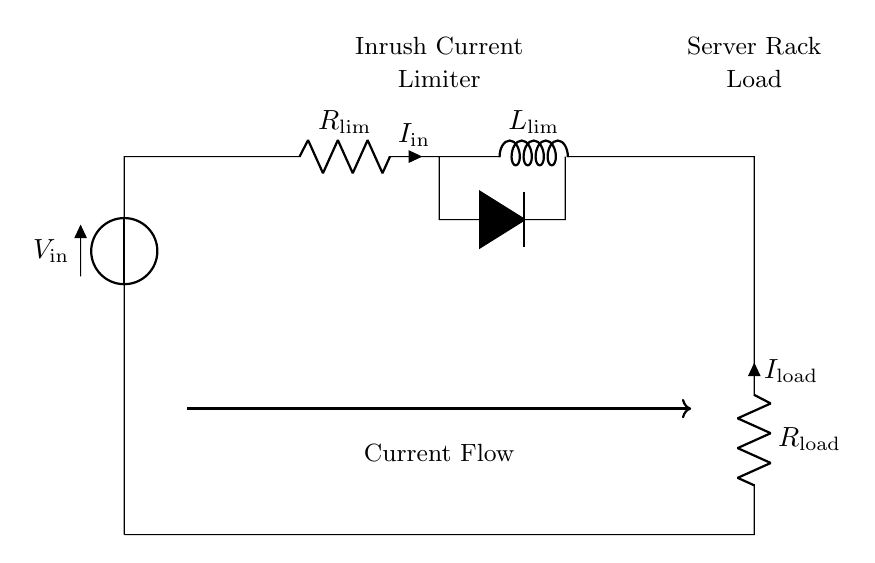What component limits inrush current? The component that limits inrush current is labeled as R_lim in the circuit diagram, which stands for the inrush current limiter resistor. It directly affects the current flow when the circuit is powered on.
Answer: R_lim What is the function of the inrush current limiter? The function of the inrush current limiter is to reduce the initial surge of current flowing into the server rack when power is applied, preventing potential damage to the components.
Answer: Reduces inrush current What is the load connected in this circuit? The load connected in this circuit is labeled as R_load, which represents the resistance of the server rack that the current flows through once the inrush current has been limited.
Answer: R_load How many components are in series in this circuit? The components that are in series are V_in, R_lim, L_lim, and R_load, resulting in a total of four components connected in series.
Answer: Four What is the type of the load in the circuit? The type of load is resistive, as indicated by the label R_load, suggesting that it primarily consumes electrical power in the form of resistive heat, common in server racks.
Answer: Resistive What happens to I_in when L_lim is present? The presence of L_lim (the inductor) in the circuit causes the inrush current I_in to rise more gradually due to the inductive reactance, slowing the rate of change in current and limiting sudden spikes to protect the load.
Answer: Gradually increases What is the current direction through the server rack? The direction of current flow through the server rack is indicated by the arrow in the circuit diagram, moving from the input voltage (V_in) through R_load, indicating that the current flows from the source towards the load.
Answer: From V_in to R_load 